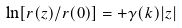<formula> <loc_0><loc_0><loc_500><loc_500>\ln [ r ( z ) / r ( 0 ) ] = + \gamma ( k ) | z |</formula> 